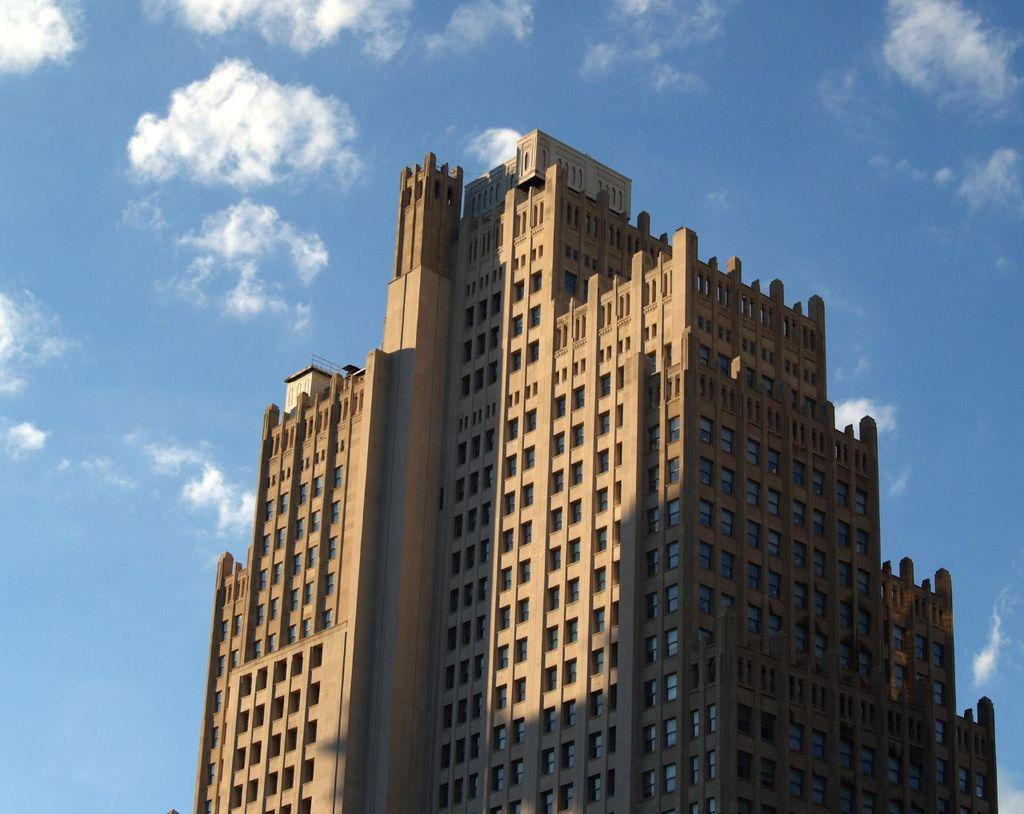What is the main structure in the image? There is a building in the image. What feature of the building is mentioned in the facts? The building has a group of windows. What can be seen in the background of the image? The sky is visible in the background of the image. How would you describe the sky in the image? The sky appears to be cloudy. Can you see a receipt on the windowsill in the image? There is no mention of a receipt in the provided facts, and therefore it cannot be confirmed if one is present in the image. 